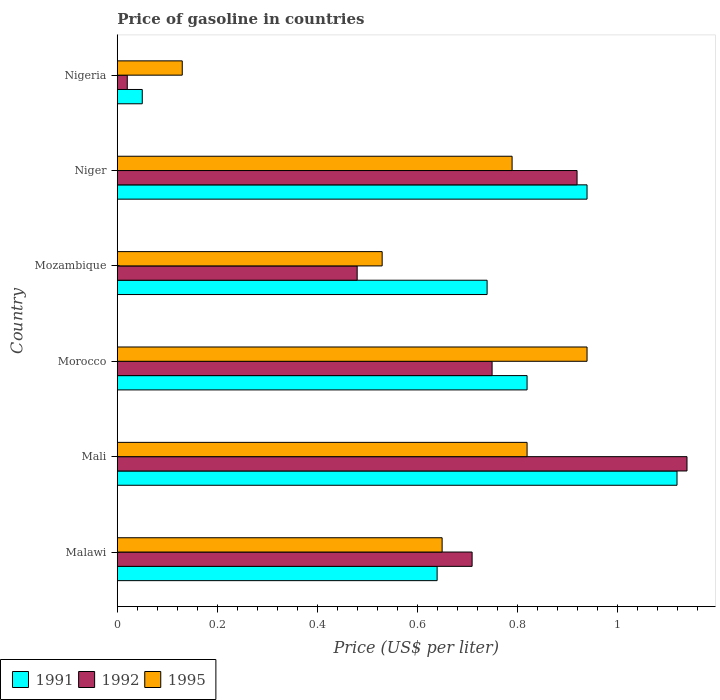How many groups of bars are there?
Make the answer very short. 6. Are the number of bars per tick equal to the number of legend labels?
Offer a very short reply. Yes. Are the number of bars on each tick of the Y-axis equal?
Your response must be concise. Yes. How many bars are there on the 6th tick from the top?
Offer a terse response. 3. How many bars are there on the 5th tick from the bottom?
Your answer should be compact. 3. What is the label of the 6th group of bars from the top?
Keep it short and to the point. Malawi. Across all countries, what is the maximum price of gasoline in 1992?
Make the answer very short. 1.14. In which country was the price of gasoline in 1992 maximum?
Ensure brevity in your answer.  Mali. In which country was the price of gasoline in 1995 minimum?
Your answer should be compact. Nigeria. What is the total price of gasoline in 1992 in the graph?
Your answer should be compact. 4.02. What is the difference between the price of gasoline in 1991 in Mozambique and that in Niger?
Make the answer very short. -0.2. What is the difference between the price of gasoline in 1995 in Malawi and the price of gasoline in 1991 in Mali?
Make the answer very short. -0.47. What is the average price of gasoline in 1995 per country?
Your response must be concise. 0.64. What is the difference between the price of gasoline in 1995 and price of gasoline in 1991 in Mali?
Offer a terse response. -0.3. What is the ratio of the price of gasoline in 1995 in Mali to that in Mozambique?
Make the answer very short. 1.55. Is the difference between the price of gasoline in 1995 in Mali and Nigeria greater than the difference between the price of gasoline in 1991 in Mali and Nigeria?
Offer a very short reply. No. What is the difference between the highest and the second highest price of gasoline in 1992?
Your answer should be very brief. 0.22. What is the difference between the highest and the lowest price of gasoline in 1995?
Your response must be concise. 0.81. In how many countries, is the price of gasoline in 1995 greater than the average price of gasoline in 1995 taken over all countries?
Make the answer very short. 4. What does the 3rd bar from the top in Nigeria represents?
Your response must be concise. 1991. What does the 3rd bar from the bottom in Morocco represents?
Provide a short and direct response. 1995. How many bars are there?
Provide a short and direct response. 18. Are all the bars in the graph horizontal?
Ensure brevity in your answer.  Yes. How many countries are there in the graph?
Provide a succinct answer. 6. Are the values on the major ticks of X-axis written in scientific E-notation?
Your answer should be compact. No. Does the graph contain grids?
Keep it short and to the point. No. Where does the legend appear in the graph?
Ensure brevity in your answer.  Bottom left. How many legend labels are there?
Provide a succinct answer. 3. What is the title of the graph?
Offer a terse response. Price of gasoline in countries. Does "2002" appear as one of the legend labels in the graph?
Your response must be concise. No. What is the label or title of the X-axis?
Ensure brevity in your answer.  Price (US$ per liter). What is the label or title of the Y-axis?
Your answer should be compact. Country. What is the Price (US$ per liter) of 1991 in Malawi?
Make the answer very short. 0.64. What is the Price (US$ per liter) of 1992 in Malawi?
Your answer should be compact. 0.71. What is the Price (US$ per liter) in 1995 in Malawi?
Your answer should be very brief. 0.65. What is the Price (US$ per liter) in 1991 in Mali?
Your answer should be compact. 1.12. What is the Price (US$ per liter) in 1992 in Mali?
Ensure brevity in your answer.  1.14. What is the Price (US$ per liter) of 1995 in Mali?
Provide a short and direct response. 0.82. What is the Price (US$ per liter) in 1991 in Morocco?
Give a very brief answer. 0.82. What is the Price (US$ per liter) in 1991 in Mozambique?
Give a very brief answer. 0.74. What is the Price (US$ per liter) of 1992 in Mozambique?
Ensure brevity in your answer.  0.48. What is the Price (US$ per liter) of 1995 in Mozambique?
Your response must be concise. 0.53. What is the Price (US$ per liter) in 1995 in Niger?
Your answer should be very brief. 0.79. What is the Price (US$ per liter) of 1992 in Nigeria?
Make the answer very short. 0.02. What is the Price (US$ per liter) in 1995 in Nigeria?
Keep it short and to the point. 0.13. Across all countries, what is the maximum Price (US$ per liter) of 1991?
Your answer should be very brief. 1.12. Across all countries, what is the maximum Price (US$ per liter) of 1992?
Ensure brevity in your answer.  1.14. Across all countries, what is the minimum Price (US$ per liter) in 1991?
Keep it short and to the point. 0.05. Across all countries, what is the minimum Price (US$ per liter) of 1995?
Keep it short and to the point. 0.13. What is the total Price (US$ per liter) in 1991 in the graph?
Make the answer very short. 4.31. What is the total Price (US$ per liter) in 1992 in the graph?
Provide a short and direct response. 4.02. What is the total Price (US$ per liter) of 1995 in the graph?
Offer a terse response. 3.86. What is the difference between the Price (US$ per liter) of 1991 in Malawi and that in Mali?
Ensure brevity in your answer.  -0.48. What is the difference between the Price (US$ per liter) in 1992 in Malawi and that in Mali?
Your response must be concise. -0.43. What is the difference between the Price (US$ per liter) of 1995 in Malawi and that in Mali?
Offer a terse response. -0.17. What is the difference between the Price (US$ per liter) in 1991 in Malawi and that in Morocco?
Provide a succinct answer. -0.18. What is the difference between the Price (US$ per liter) in 1992 in Malawi and that in Morocco?
Offer a terse response. -0.04. What is the difference between the Price (US$ per liter) of 1995 in Malawi and that in Morocco?
Provide a succinct answer. -0.29. What is the difference between the Price (US$ per liter) of 1992 in Malawi and that in Mozambique?
Give a very brief answer. 0.23. What is the difference between the Price (US$ per liter) in 1995 in Malawi and that in Mozambique?
Your answer should be very brief. 0.12. What is the difference between the Price (US$ per liter) of 1992 in Malawi and that in Niger?
Your response must be concise. -0.21. What is the difference between the Price (US$ per liter) of 1995 in Malawi and that in Niger?
Keep it short and to the point. -0.14. What is the difference between the Price (US$ per liter) in 1991 in Malawi and that in Nigeria?
Your response must be concise. 0.59. What is the difference between the Price (US$ per liter) in 1992 in Malawi and that in Nigeria?
Your answer should be compact. 0.69. What is the difference between the Price (US$ per liter) in 1995 in Malawi and that in Nigeria?
Offer a very short reply. 0.52. What is the difference between the Price (US$ per liter) in 1991 in Mali and that in Morocco?
Your response must be concise. 0.3. What is the difference between the Price (US$ per liter) of 1992 in Mali and that in Morocco?
Make the answer very short. 0.39. What is the difference between the Price (US$ per liter) of 1995 in Mali and that in Morocco?
Provide a short and direct response. -0.12. What is the difference between the Price (US$ per liter) of 1991 in Mali and that in Mozambique?
Offer a very short reply. 0.38. What is the difference between the Price (US$ per liter) of 1992 in Mali and that in Mozambique?
Give a very brief answer. 0.66. What is the difference between the Price (US$ per liter) in 1995 in Mali and that in Mozambique?
Ensure brevity in your answer.  0.29. What is the difference between the Price (US$ per liter) of 1991 in Mali and that in Niger?
Provide a short and direct response. 0.18. What is the difference between the Price (US$ per liter) of 1992 in Mali and that in Niger?
Your response must be concise. 0.22. What is the difference between the Price (US$ per liter) in 1995 in Mali and that in Niger?
Your response must be concise. 0.03. What is the difference between the Price (US$ per liter) in 1991 in Mali and that in Nigeria?
Provide a short and direct response. 1.07. What is the difference between the Price (US$ per liter) in 1992 in Mali and that in Nigeria?
Keep it short and to the point. 1.12. What is the difference between the Price (US$ per liter) of 1995 in Mali and that in Nigeria?
Make the answer very short. 0.69. What is the difference between the Price (US$ per liter) in 1992 in Morocco and that in Mozambique?
Provide a succinct answer. 0.27. What is the difference between the Price (US$ per liter) in 1995 in Morocco and that in Mozambique?
Your answer should be very brief. 0.41. What is the difference between the Price (US$ per liter) in 1991 in Morocco and that in Niger?
Offer a terse response. -0.12. What is the difference between the Price (US$ per liter) in 1992 in Morocco and that in Niger?
Your response must be concise. -0.17. What is the difference between the Price (US$ per liter) of 1991 in Morocco and that in Nigeria?
Provide a short and direct response. 0.77. What is the difference between the Price (US$ per liter) of 1992 in Morocco and that in Nigeria?
Provide a short and direct response. 0.73. What is the difference between the Price (US$ per liter) of 1995 in Morocco and that in Nigeria?
Offer a very short reply. 0.81. What is the difference between the Price (US$ per liter) in 1992 in Mozambique and that in Niger?
Your response must be concise. -0.44. What is the difference between the Price (US$ per liter) of 1995 in Mozambique and that in Niger?
Your answer should be compact. -0.26. What is the difference between the Price (US$ per liter) in 1991 in Mozambique and that in Nigeria?
Provide a succinct answer. 0.69. What is the difference between the Price (US$ per liter) in 1992 in Mozambique and that in Nigeria?
Make the answer very short. 0.46. What is the difference between the Price (US$ per liter) of 1991 in Niger and that in Nigeria?
Offer a very short reply. 0.89. What is the difference between the Price (US$ per liter) of 1992 in Niger and that in Nigeria?
Your response must be concise. 0.9. What is the difference between the Price (US$ per liter) of 1995 in Niger and that in Nigeria?
Offer a terse response. 0.66. What is the difference between the Price (US$ per liter) in 1991 in Malawi and the Price (US$ per liter) in 1995 in Mali?
Make the answer very short. -0.18. What is the difference between the Price (US$ per liter) in 1992 in Malawi and the Price (US$ per liter) in 1995 in Mali?
Keep it short and to the point. -0.11. What is the difference between the Price (US$ per liter) of 1991 in Malawi and the Price (US$ per liter) of 1992 in Morocco?
Offer a terse response. -0.11. What is the difference between the Price (US$ per liter) in 1992 in Malawi and the Price (US$ per liter) in 1995 in Morocco?
Your response must be concise. -0.23. What is the difference between the Price (US$ per liter) in 1991 in Malawi and the Price (US$ per liter) in 1992 in Mozambique?
Ensure brevity in your answer.  0.16. What is the difference between the Price (US$ per liter) in 1991 in Malawi and the Price (US$ per liter) in 1995 in Mozambique?
Offer a very short reply. 0.11. What is the difference between the Price (US$ per liter) in 1992 in Malawi and the Price (US$ per liter) in 1995 in Mozambique?
Keep it short and to the point. 0.18. What is the difference between the Price (US$ per liter) of 1991 in Malawi and the Price (US$ per liter) of 1992 in Niger?
Make the answer very short. -0.28. What is the difference between the Price (US$ per liter) of 1992 in Malawi and the Price (US$ per liter) of 1995 in Niger?
Your response must be concise. -0.08. What is the difference between the Price (US$ per liter) of 1991 in Malawi and the Price (US$ per liter) of 1992 in Nigeria?
Offer a terse response. 0.62. What is the difference between the Price (US$ per liter) of 1991 in Malawi and the Price (US$ per liter) of 1995 in Nigeria?
Keep it short and to the point. 0.51. What is the difference between the Price (US$ per liter) of 1992 in Malawi and the Price (US$ per liter) of 1995 in Nigeria?
Offer a very short reply. 0.58. What is the difference between the Price (US$ per liter) in 1991 in Mali and the Price (US$ per liter) in 1992 in Morocco?
Give a very brief answer. 0.37. What is the difference between the Price (US$ per liter) in 1991 in Mali and the Price (US$ per liter) in 1995 in Morocco?
Provide a short and direct response. 0.18. What is the difference between the Price (US$ per liter) of 1992 in Mali and the Price (US$ per liter) of 1995 in Morocco?
Keep it short and to the point. 0.2. What is the difference between the Price (US$ per liter) in 1991 in Mali and the Price (US$ per liter) in 1992 in Mozambique?
Give a very brief answer. 0.64. What is the difference between the Price (US$ per liter) in 1991 in Mali and the Price (US$ per liter) in 1995 in Mozambique?
Your answer should be very brief. 0.59. What is the difference between the Price (US$ per liter) in 1992 in Mali and the Price (US$ per liter) in 1995 in Mozambique?
Give a very brief answer. 0.61. What is the difference between the Price (US$ per liter) of 1991 in Mali and the Price (US$ per liter) of 1995 in Niger?
Make the answer very short. 0.33. What is the difference between the Price (US$ per liter) in 1991 in Mali and the Price (US$ per liter) in 1992 in Nigeria?
Your response must be concise. 1.1. What is the difference between the Price (US$ per liter) in 1991 in Mali and the Price (US$ per liter) in 1995 in Nigeria?
Make the answer very short. 0.99. What is the difference between the Price (US$ per liter) in 1991 in Morocco and the Price (US$ per liter) in 1992 in Mozambique?
Give a very brief answer. 0.34. What is the difference between the Price (US$ per liter) of 1991 in Morocco and the Price (US$ per liter) of 1995 in Mozambique?
Make the answer very short. 0.29. What is the difference between the Price (US$ per liter) in 1992 in Morocco and the Price (US$ per liter) in 1995 in Mozambique?
Keep it short and to the point. 0.22. What is the difference between the Price (US$ per liter) in 1992 in Morocco and the Price (US$ per liter) in 1995 in Niger?
Your answer should be compact. -0.04. What is the difference between the Price (US$ per liter) of 1991 in Morocco and the Price (US$ per liter) of 1992 in Nigeria?
Give a very brief answer. 0.8. What is the difference between the Price (US$ per liter) in 1991 in Morocco and the Price (US$ per liter) in 1995 in Nigeria?
Your answer should be compact. 0.69. What is the difference between the Price (US$ per liter) in 1992 in Morocco and the Price (US$ per liter) in 1995 in Nigeria?
Make the answer very short. 0.62. What is the difference between the Price (US$ per liter) in 1991 in Mozambique and the Price (US$ per liter) in 1992 in Niger?
Provide a succinct answer. -0.18. What is the difference between the Price (US$ per liter) in 1991 in Mozambique and the Price (US$ per liter) in 1995 in Niger?
Your response must be concise. -0.05. What is the difference between the Price (US$ per liter) of 1992 in Mozambique and the Price (US$ per liter) of 1995 in Niger?
Offer a terse response. -0.31. What is the difference between the Price (US$ per liter) of 1991 in Mozambique and the Price (US$ per liter) of 1992 in Nigeria?
Ensure brevity in your answer.  0.72. What is the difference between the Price (US$ per liter) in 1991 in Mozambique and the Price (US$ per liter) in 1995 in Nigeria?
Your response must be concise. 0.61. What is the difference between the Price (US$ per liter) in 1992 in Mozambique and the Price (US$ per liter) in 1995 in Nigeria?
Offer a very short reply. 0.35. What is the difference between the Price (US$ per liter) of 1991 in Niger and the Price (US$ per liter) of 1995 in Nigeria?
Make the answer very short. 0.81. What is the difference between the Price (US$ per liter) in 1992 in Niger and the Price (US$ per liter) in 1995 in Nigeria?
Offer a terse response. 0.79. What is the average Price (US$ per liter) in 1991 per country?
Ensure brevity in your answer.  0.72. What is the average Price (US$ per liter) in 1992 per country?
Your response must be concise. 0.67. What is the average Price (US$ per liter) in 1995 per country?
Provide a short and direct response. 0.64. What is the difference between the Price (US$ per liter) of 1991 and Price (US$ per liter) of 1992 in Malawi?
Provide a succinct answer. -0.07. What is the difference between the Price (US$ per liter) in 1991 and Price (US$ per liter) in 1995 in Malawi?
Offer a very short reply. -0.01. What is the difference between the Price (US$ per liter) of 1991 and Price (US$ per liter) of 1992 in Mali?
Your answer should be very brief. -0.02. What is the difference between the Price (US$ per liter) of 1991 and Price (US$ per liter) of 1995 in Mali?
Give a very brief answer. 0.3. What is the difference between the Price (US$ per liter) in 1992 and Price (US$ per liter) in 1995 in Mali?
Keep it short and to the point. 0.32. What is the difference between the Price (US$ per liter) in 1991 and Price (US$ per liter) in 1992 in Morocco?
Your answer should be very brief. 0.07. What is the difference between the Price (US$ per liter) of 1991 and Price (US$ per liter) of 1995 in Morocco?
Your answer should be very brief. -0.12. What is the difference between the Price (US$ per liter) of 1992 and Price (US$ per liter) of 1995 in Morocco?
Keep it short and to the point. -0.19. What is the difference between the Price (US$ per liter) in 1991 and Price (US$ per liter) in 1992 in Mozambique?
Make the answer very short. 0.26. What is the difference between the Price (US$ per liter) of 1991 and Price (US$ per liter) of 1995 in Mozambique?
Your answer should be compact. 0.21. What is the difference between the Price (US$ per liter) in 1991 and Price (US$ per liter) in 1992 in Niger?
Offer a terse response. 0.02. What is the difference between the Price (US$ per liter) of 1991 and Price (US$ per liter) of 1995 in Niger?
Make the answer very short. 0.15. What is the difference between the Price (US$ per liter) in 1992 and Price (US$ per liter) in 1995 in Niger?
Offer a terse response. 0.13. What is the difference between the Price (US$ per liter) of 1991 and Price (US$ per liter) of 1995 in Nigeria?
Ensure brevity in your answer.  -0.08. What is the difference between the Price (US$ per liter) in 1992 and Price (US$ per liter) in 1995 in Nigeria?
Provide a succinct answer. -0.11. What is the ratio of the Price (US$ per liter) in 1991 in Malawi to that in Mali?
Give a very brief answer. 0.57. What is the ratio of the Price (US$ per liter) of 1992 in Malawi to that in Mali?
Provide a succinct answer. 0.62. What is the ratio of the Price (US$ per liter) in 1995 in Malawi to that in Mali?
Offer a very short reply. 0.79. What is the ratio of the Price (US$ per liter) in 1991 in Malawi to that in Morocco?
Make the answer very short. 0.78. What is the ratio of the Price (US$ per liter) of 1992 in Malawi to that in Morocco?
Your answer should be compact. 0.95. What is the ratio of the Price (US$ per liter) in 1995 in Malawi to that in Morocco?
Your response must be concise. 0.69. What is the ratio of the Price (US$ per liter) in 1991 in Malawi to that in Mozambique?
Keep it short and to the point. 0.86. What is the ratio of the Price (US$ per liter) in 1992 in Malawi to that in Mozambique?
Your response must be concise. 1.48. What is the ratio of the Price (US$ per liter) of 1995 in Malawi to that in Mozambique?
Ensure brevity in your answer.  1.23. What is the ratio of the Price (US$ per liter) in 1991 in Malawi to that in Niger?
Give a very brief answer. 0.68. What is the ratio of the Price (US$ per liter) of 1992 in Malawi to that in Niger?
Give a very brief answer. 0.77. What is the ratio of the Price (US$ per liter) of 1995 in Malawi to that in Niger?
Your answer should be compact. 0.82. What is the ratio of the Price (US$ per liter) of 1991 in Malawi to that in Nigeria?
Make the answer very short. 12.8. What is the ratio of the Price (US$ per liter) of 1992 in Malawi to that in Nigeria?
Your answer should be very brief. 35.5. What is the ratio of the Price (US$ per liter) of 1995 in Malawi to that in Nigeria?
Keep it short and to the point. 5. What is the ratio of the Price (US$ per liter) of 1991 in Mali to that in Morocco?
Offer a very short reply. 1.37. What is the ratio of the Price (US$ per liter) of 1992 in Mali to that in Morocco?
Offer a very short reply. 1.52. What is the ratio of the Price (US$ per liter) of 1995 in Mali to that in Morocco?
Your response must be concise. 0.87. What is the ratio of the Price (US$ per liter) in 1991 in Mali to that in Mozambique?
Offer a very short reply. 1.51. What is the ratio of the Price (US$ per liter) in 1992 in Mali to that in Mozambique?
Your answer should be compact. 2.38. What is the ratio of the Price (US$ per liter) of 1995 in Mali to that in Mozambique?
Offer a terse response. 1.55. What is the ratio of the Price (US$ per liter) in 1991 in Mali to that in Niger?
Keep it short and to the point. 1.19. What is the ratio of the Price (US$ per liter) in 1992 in Mali to that in Niger?
Ensure brevity in your answer.  1.24. What is the ratio of the Price (US$ per liter) in 1995 in Mali to that in Niger?
Ensure brevity in your answer.  1.04. What is the ratio of the Price (US$ per liter) in 1991 in Mali to that in Nigeria?
Make the answer very short. 22.4. What is the ratio of the Price (US$ per liter) in 1995 in Mali to that in Nigeria?
Provide a short and direct response. 6.31. What is the ratio of the Price (US$ per liter) in 1991 in Morocco to that in Mozambique?
Make the answer very short. 1.11. What is the ratio of the Price (US$ per liter) in 1992 in Morocco to that in Mozambique?
Offer a very short reply. 1.56. What is the ratio of the Price (US$ per liter) of 1995 in Morocco to that in Mozambique?
Your response must be concise. 1.77. What is the ratio of the Price (US$ per liter) in 1991 in Morocco to that in Niger?
Keep it short and to the point. 0.87. What is the ratio of the Price (US$ per liter) of 1992 in Morocco to that in Niger?
Provide a succinct answer. 0.82. What is the ratio of the Price (US$ per liter) of 1995 in Morocco to that in Niger?
Provide a succinct answer. 1.19. What is the ratio of the Price (US$ per liter) in 1992 in Morocco to that in Nigeria?
Offer a terse response. 37.5. What is the ratio of the Price (US$ per liter) in 1995 in Morocco to that in Nigeria?
Offer a very short reply. 7.23. What is the ratio of the Price (US$ per liter) of 1991 in Mozambique to that in Niger?
Your answer should be compact. 0.79. What is the ratio of the Price (US$ per liter) of 1992 in Mozambique to that in Niger?
Ensure brevity in your answer.  0.52. What is the ratio of the Price (US$ per liter) in 1995 in Mozambique to that in Niger?
Your response must be concise. 0.67. What is the ratio of the Price (US$ per liter) in 1991 in Mozambique to that in Nigeria?
Offer a terse response. 14.8. What is the ratio of the Price (US$ per liter) in 1995 in Mozambique to that in Nigeria?
Provide a succinct answer. 4.08. What is the ratio of the Price (US$ per liter) in 1992 in Niger to that in Nigeria?
Provide a short and direct response. 46. What is the ratio of the Price (US$ per liter) of 1995 in Niger to that in Nigeria?
Offer a very short reply. 6.08. What is the difference between the highest and the second highest Price (US$ per liter) of 1991?
Keep it short and to the point. 0.18. What is the difference between the highest and the second highest Price (US$ per liter) in 1992?
Your answer should be compact. 0.22. What is the difference between the highest and the second highest Price (US$ per liter) in 1995?
Provide a succinct answer. 0.12. What is the difference between the highest and the lowest Price (US$ per liter) of 1991?
Offer a very short reply. 1.07. What is the difference between the highest and the lowest Price (US$ per liter) of 1992?
Make the answer very short. 1.12. What is the difference between the highest and the lowest Price (US$ per liter) of 1995?
Ensure brevity in your answer.  0.81. 